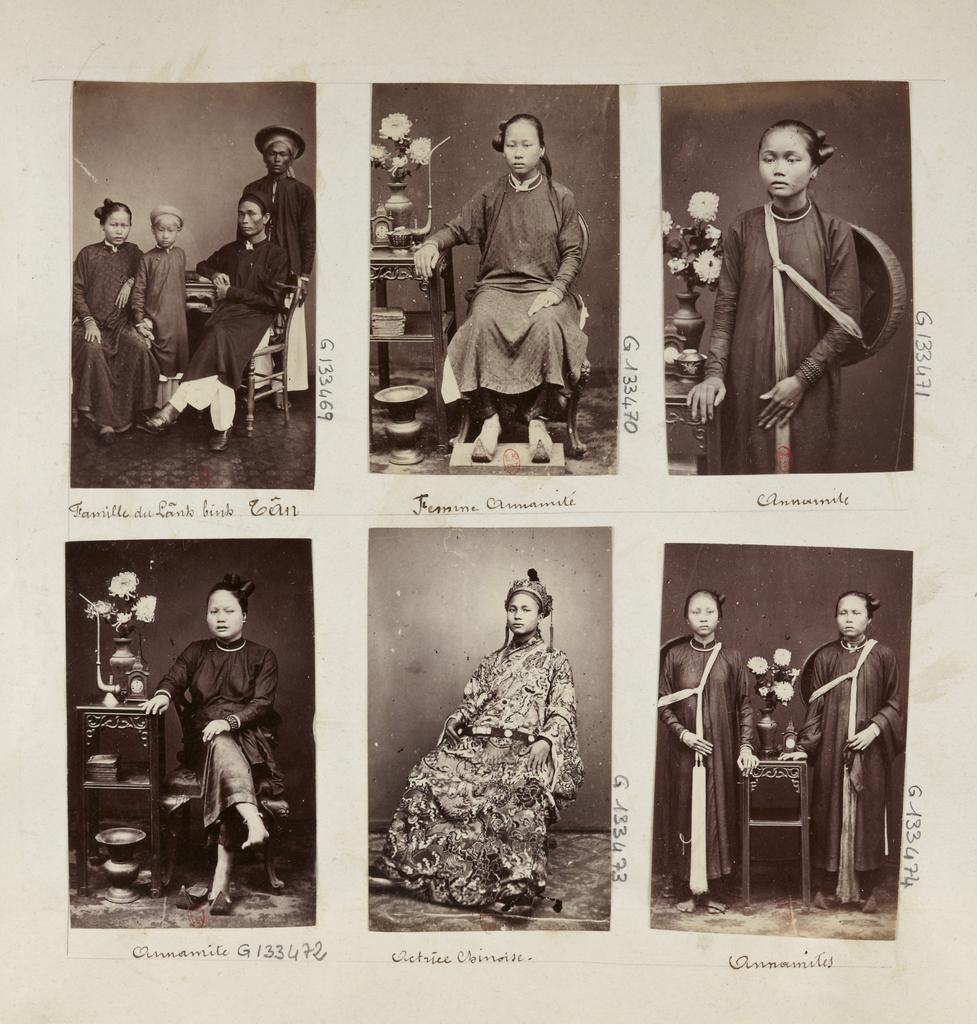What type of artwork is shown in the image? The image is a collage of 6 images. What are the people in the images doing? There are persons sitting and standing in the images. Is there any text present in the image? Yes, there is text written on the image. What objects can be seen in the images? There are flower vases in the images. What type of honey is being used to write the text in the image? There is no honey present in the image, and the text is not written with honey. Are there any spies visible in the image? There are no spies depicted in the image. 